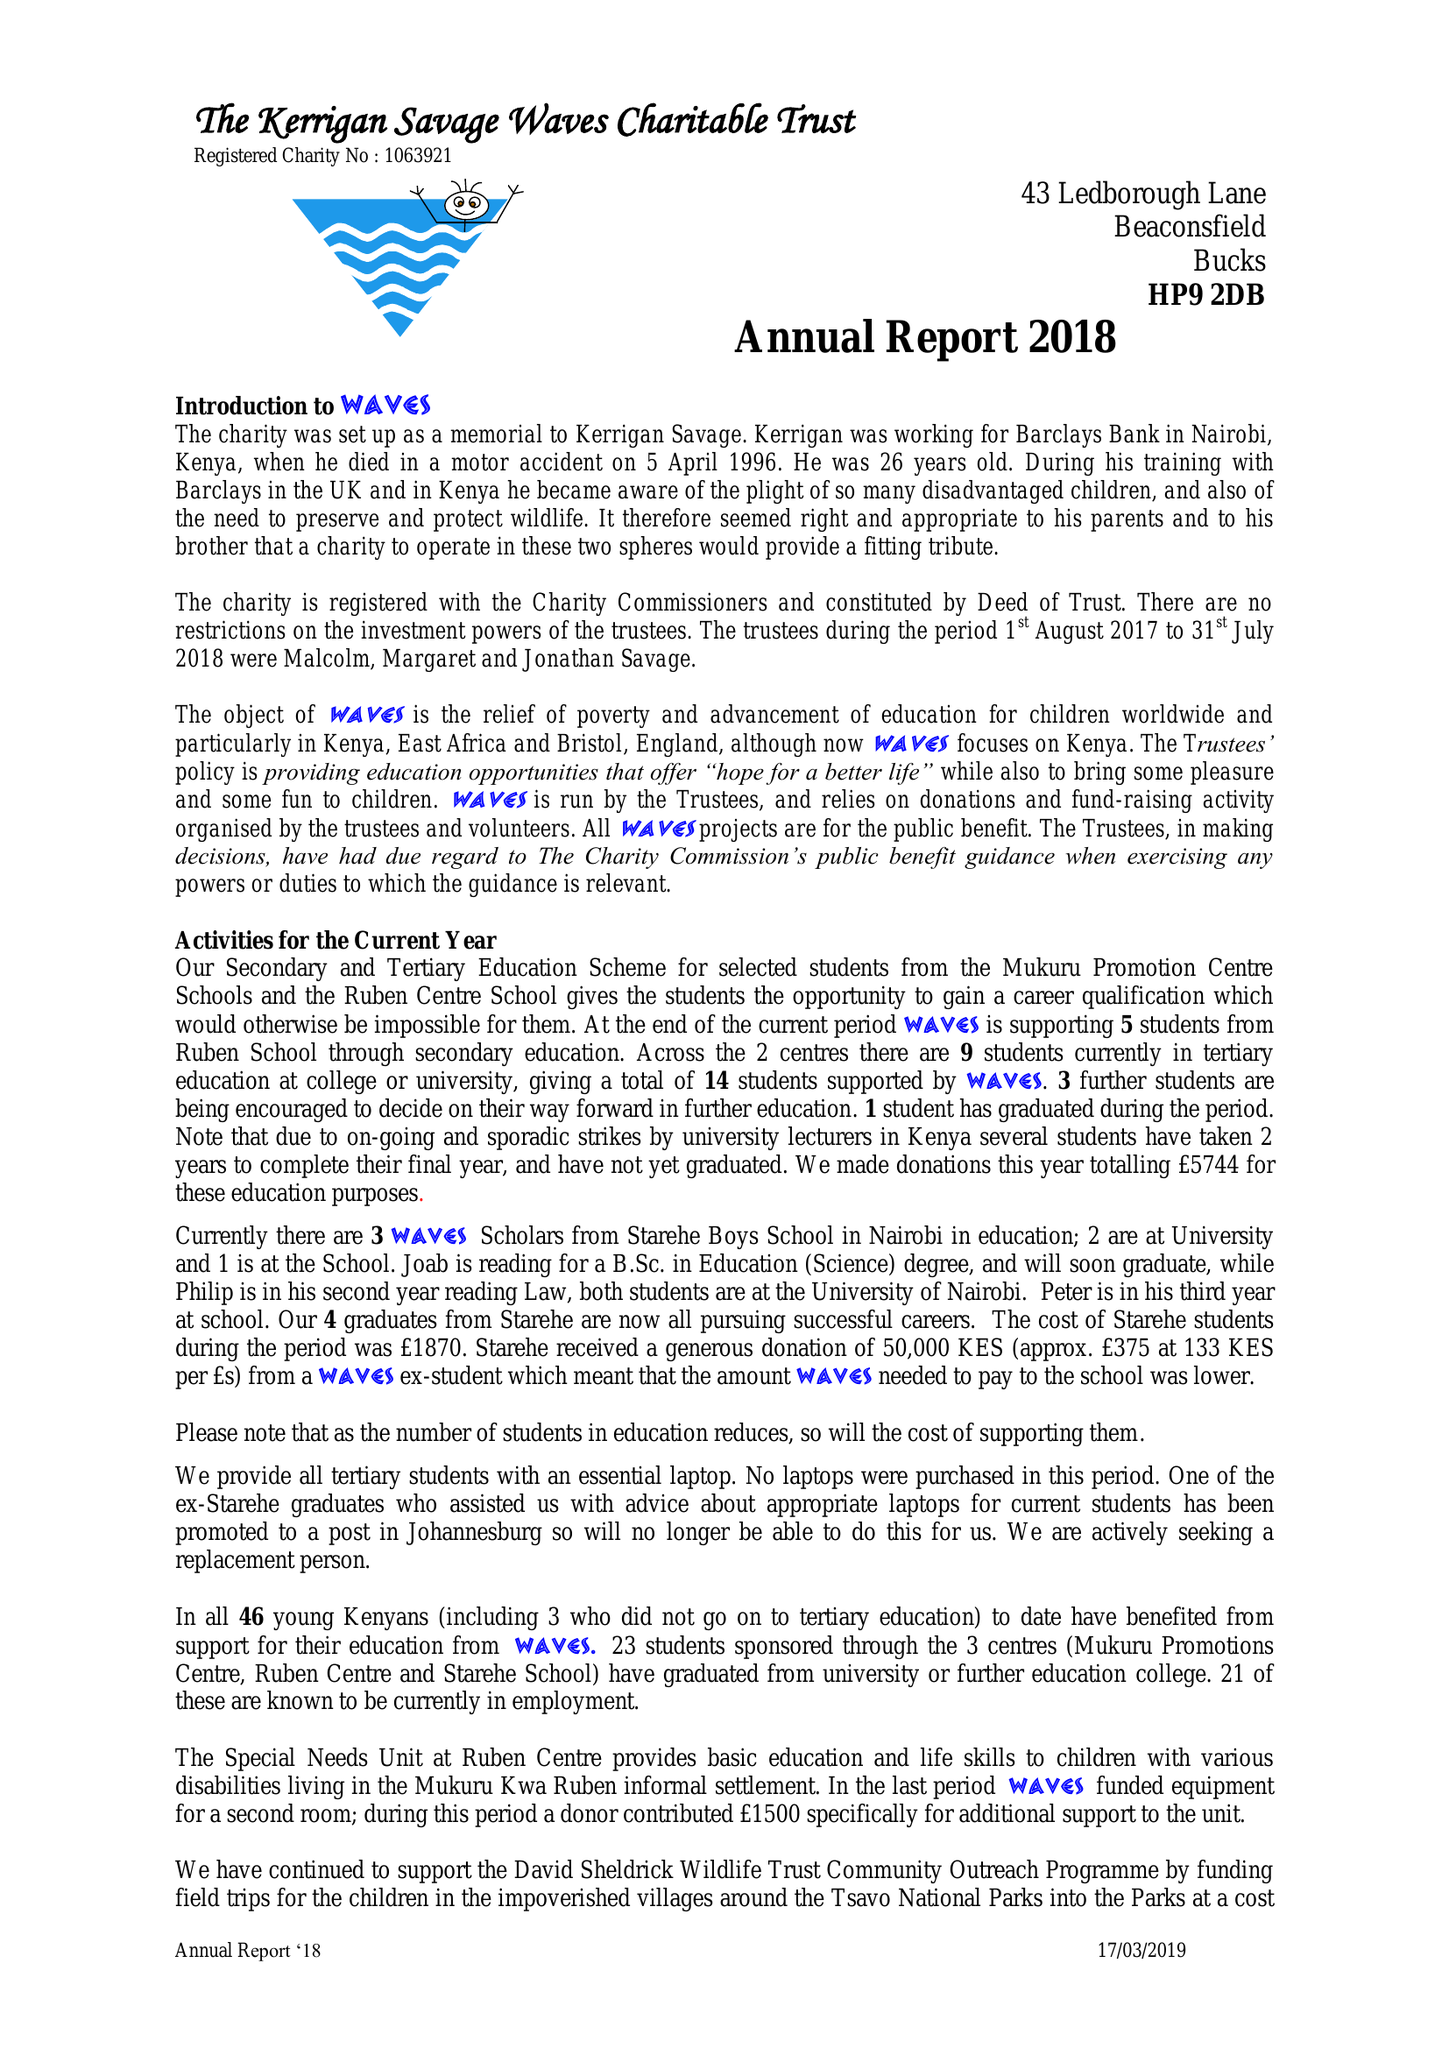What is the value for the address__post_town?
Answer the question using a single word or phrase. BEACONSFIELD 